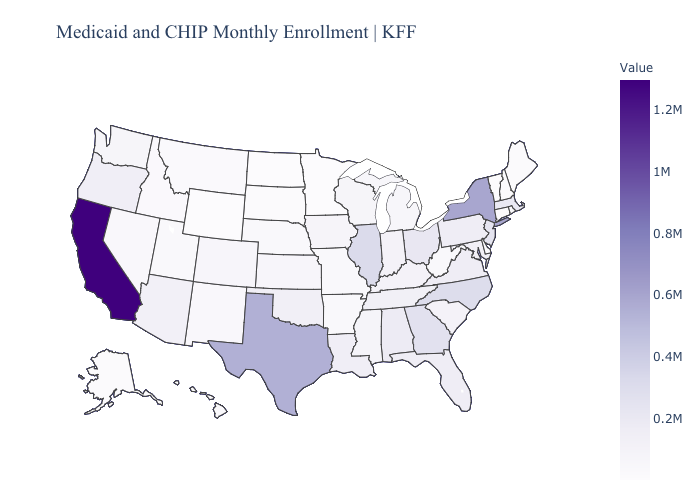Does Georgia have the lowest value in the USA?
Answer briefly. No. Among the states that border Washington , does Oregon have the highest value?
Give a very brief answer. Yes. Does the map have missing data?
Answer briefly. No. Among the states that border Indiana , which have the highest value?
Quick response, please. Illinois. Which states have the highest value in the USA?
Write a very short answer. California. 